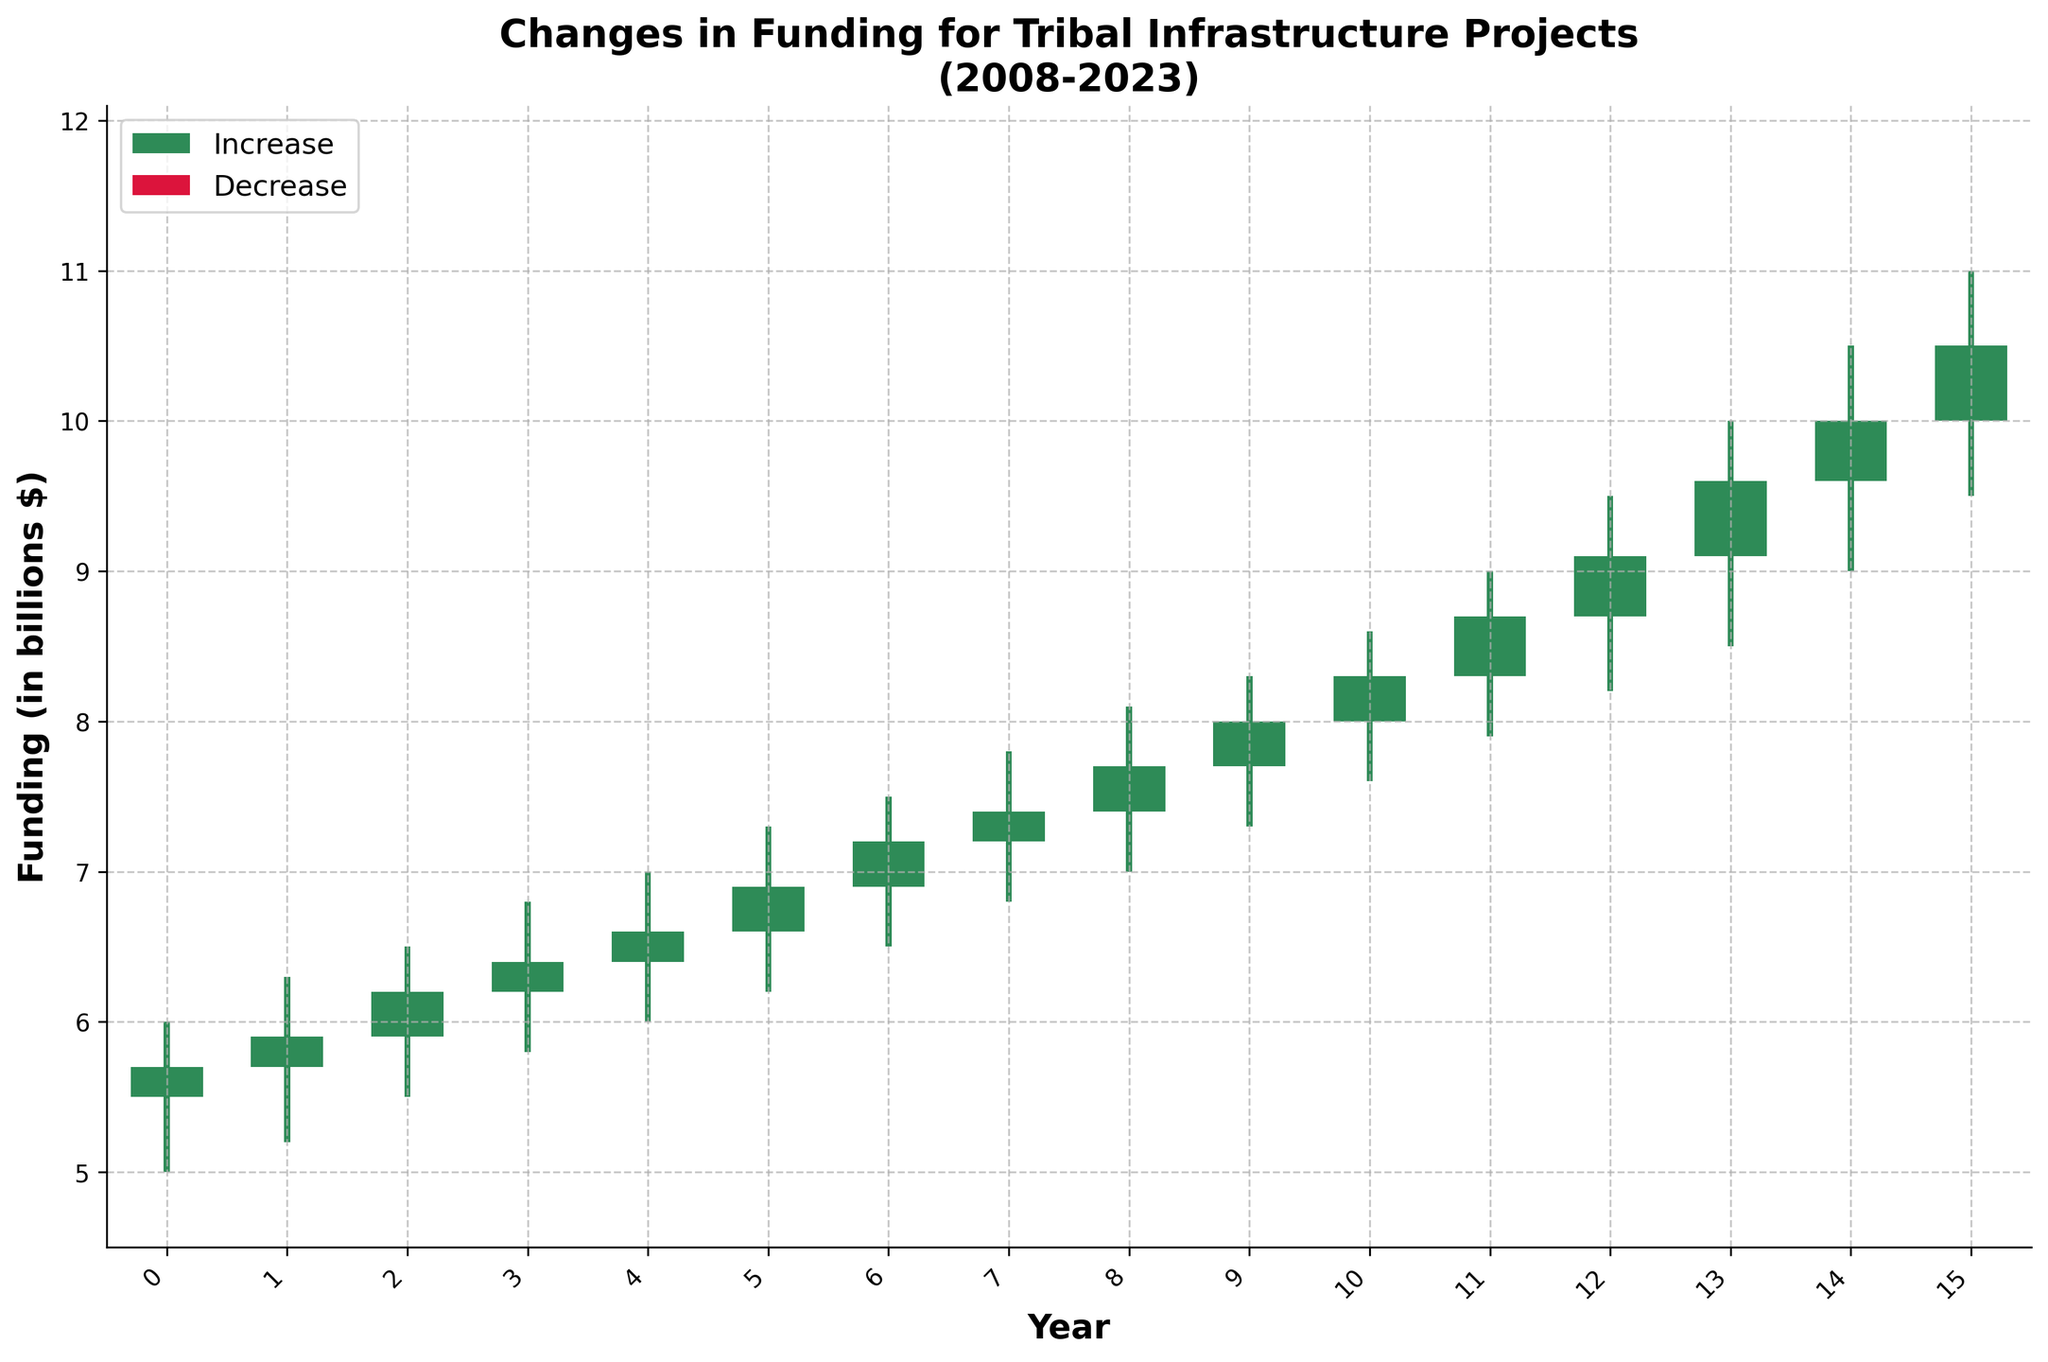What is the highest funding recorded over the 15-year period? The highest funding corresponds to the "High" values. From the candlestick plot, the highest "High" value is identified in 2023.
Answer: 11.0 billion $ What is the title of the figure? The title is located at the top of the figure.
Answer: Changes in Funding for Tribal Infrastructure Projects (2008-2023) How many years experienced a decrease in funding? A decrease in funding is represented by red bars in the candlestick plot. By counting the number of red bars, the number of years with a decrease can be determined.
Answer: 0 In what year did the funding first exceed 9 billion dollars at its highest point? Examine the "High" values on the candlestick plot; the funding first exceeds 9 billion dollars in 2020.
Answer: 2020 What is the range of funding in 2015? The range is the difference between the highest and lowest values in 2015. Refer to the 2015 candlestick which shows a high of 7.8 billion and a low of 6.8 billion.
Answer: 1.0 billion $ Which year had the greatest increase in funding from open to close? The magnitude of the increase in funding for each year can be determined by subtracting the "Open" value from the "Close" value. The year with the greatest difference is the one with the largest green bar.
Answer: 2017 What is the funding value at the close in 2010? The "Close" values are the top edges of the green or red rectangles representing the closing funding for each year. For 2010, it is 6.2 billion dollars.
Answer: 6.2 billion $ Between which consecutive years was the funding change the largest? To find the largest consecutive change, compare the "Close" values of consecutive years and identify the greatest change. The largest change is between 2021 and 2022.
Answer: 2021-2022 What is the average closing funding over the 15-year period? Add up all the "Close" values and divide by the number of years (15). (5.7 + 5.9 + 6.2 + 6.4 + 6.6 + 6.9 + 7.2 + 7.4 + 7.7 + 8.0 + 8.3 + 8.7 + 9.1 + 9.6 + 10.5)/15.
Answer: 7.53 billion $ What was the funding low in the year of the economic crisis, 2008? The "Low" value for 2008 can be seen at the bottom whisker of the candlestick corresponding to 2008.
Answer: 5.0 billion $ 